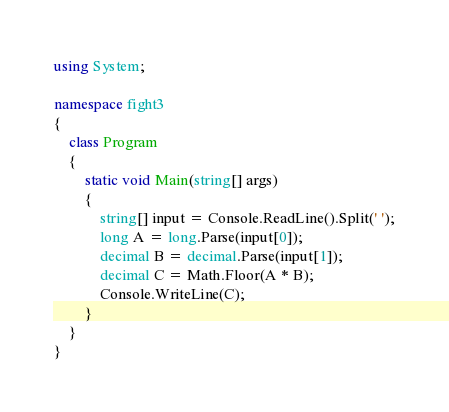Convert code to text. <code><loc_0><loc_0><loc_500><loc_500><_C#_>using System;

namespace fight3
{
    class Program
    {
        static void Main(string[] args)
        {
            string[] input = Console.ReadLine().Split(' ');
            long A = long.Parse(input[0]);
            decimal B = decimal.Parse(input[1]);
            decimal C = Math.Floor(A * B);
            Console.WriteLine(C);
        }
    }
}</code> 